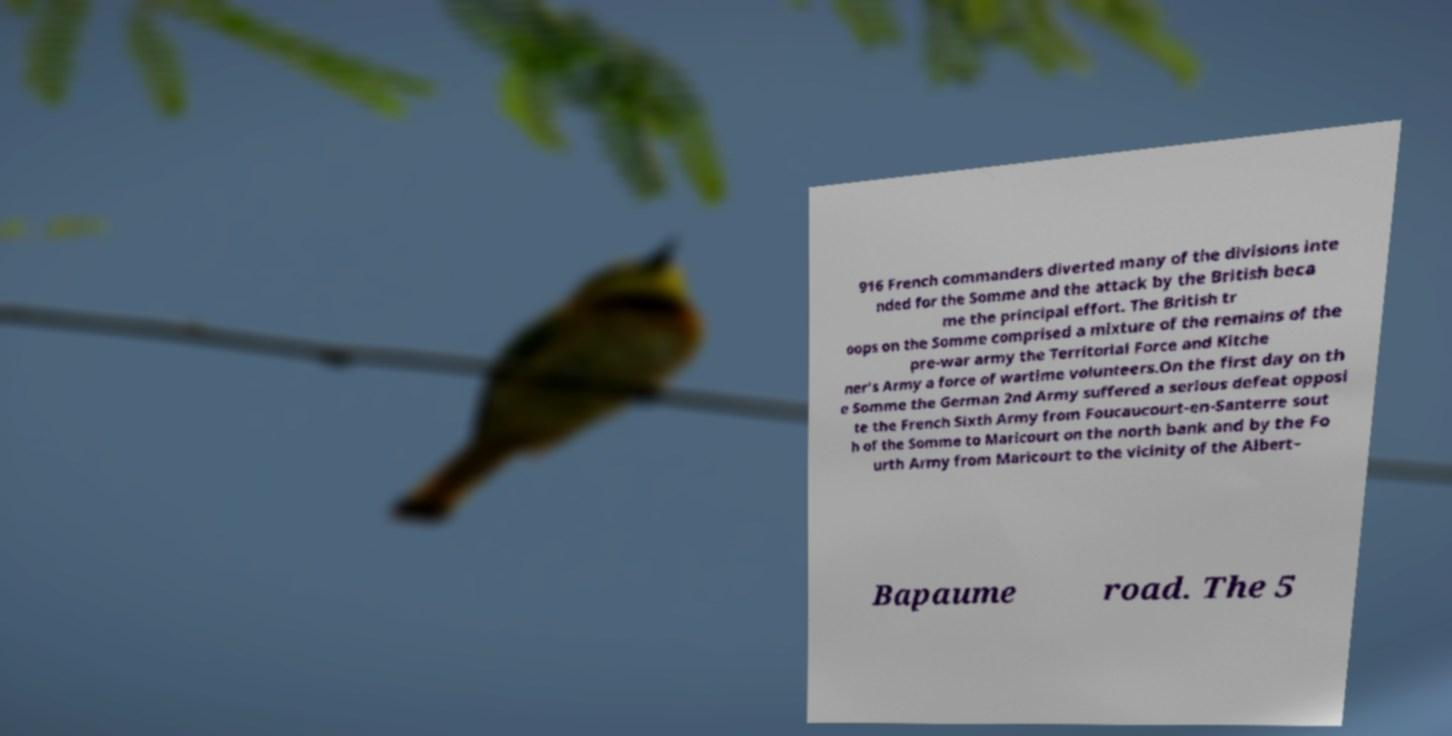Can you accurately transcribe the text from the provided image for me? 916 French commanders diverted many of the divisions inte nded for the Somme and the attack by the British beca me the principal effort. The British tr oops on the Somme comprised a mixture of the remains of the pre-war army the Territorial Force and Kitche ner's Army a force of wartime volunteers.On the first day on th e Somme the German 2nd Army suffered a serious defeat opposi te the French Sixth Army from Foucaucourt-en-Santerre sout h of the Somme to Maricourt on the north bank and by the Fo urth Army from Maricourt to the vicinity of the Albert– Bapaume road. The 5 